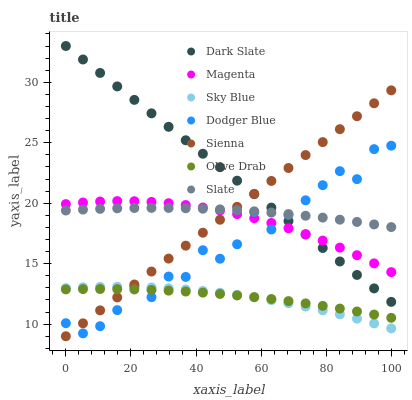Does Sky Blue have the minimum area under the curve?
Answer yes or no. Yes. Does Dark Slate have the maximum area under the curve?
Answer yes or no. Yes. Does Sienna have the minimum area under the curve?
Answer yes or no. No. Does Sienna have the maximum area under the curve?
Answer yes or no. No. Is Dark Slate the smoothest?
Answer yes or no. Yes. Is Dodger Blue the roughest?
Answer yes or no. Yes. Is Sienna the smoothest?
Answer yes or no. No. Is Sienna the roughest?
Answer yes or no. No. Does Sienna have the lowest value?
Answer yes or no. Yes. Does Dark Slate have the lowest value?
Answer yes or no. No. Does Dark Slate have the highest value?
Answer yes or no. Yes. Does Sienna have the highest value?
Answer yes or no. No. Is Sky Blue less than Dark Slate?
Answer yes or no. Yes. Is Dark Slate greater than Sky Blue?
Answer yes or no. Yes. Does Slate intersect Dodger Blue?
Answer yes or no. Yes. Is Slate less than Dodger Blue?
Answer yes or no. No. Is Slate greater than Dodger Blue?
Answer yes or no. No. Does Sky Blue intersect Dark Slate?
Answer yes or no. No. 